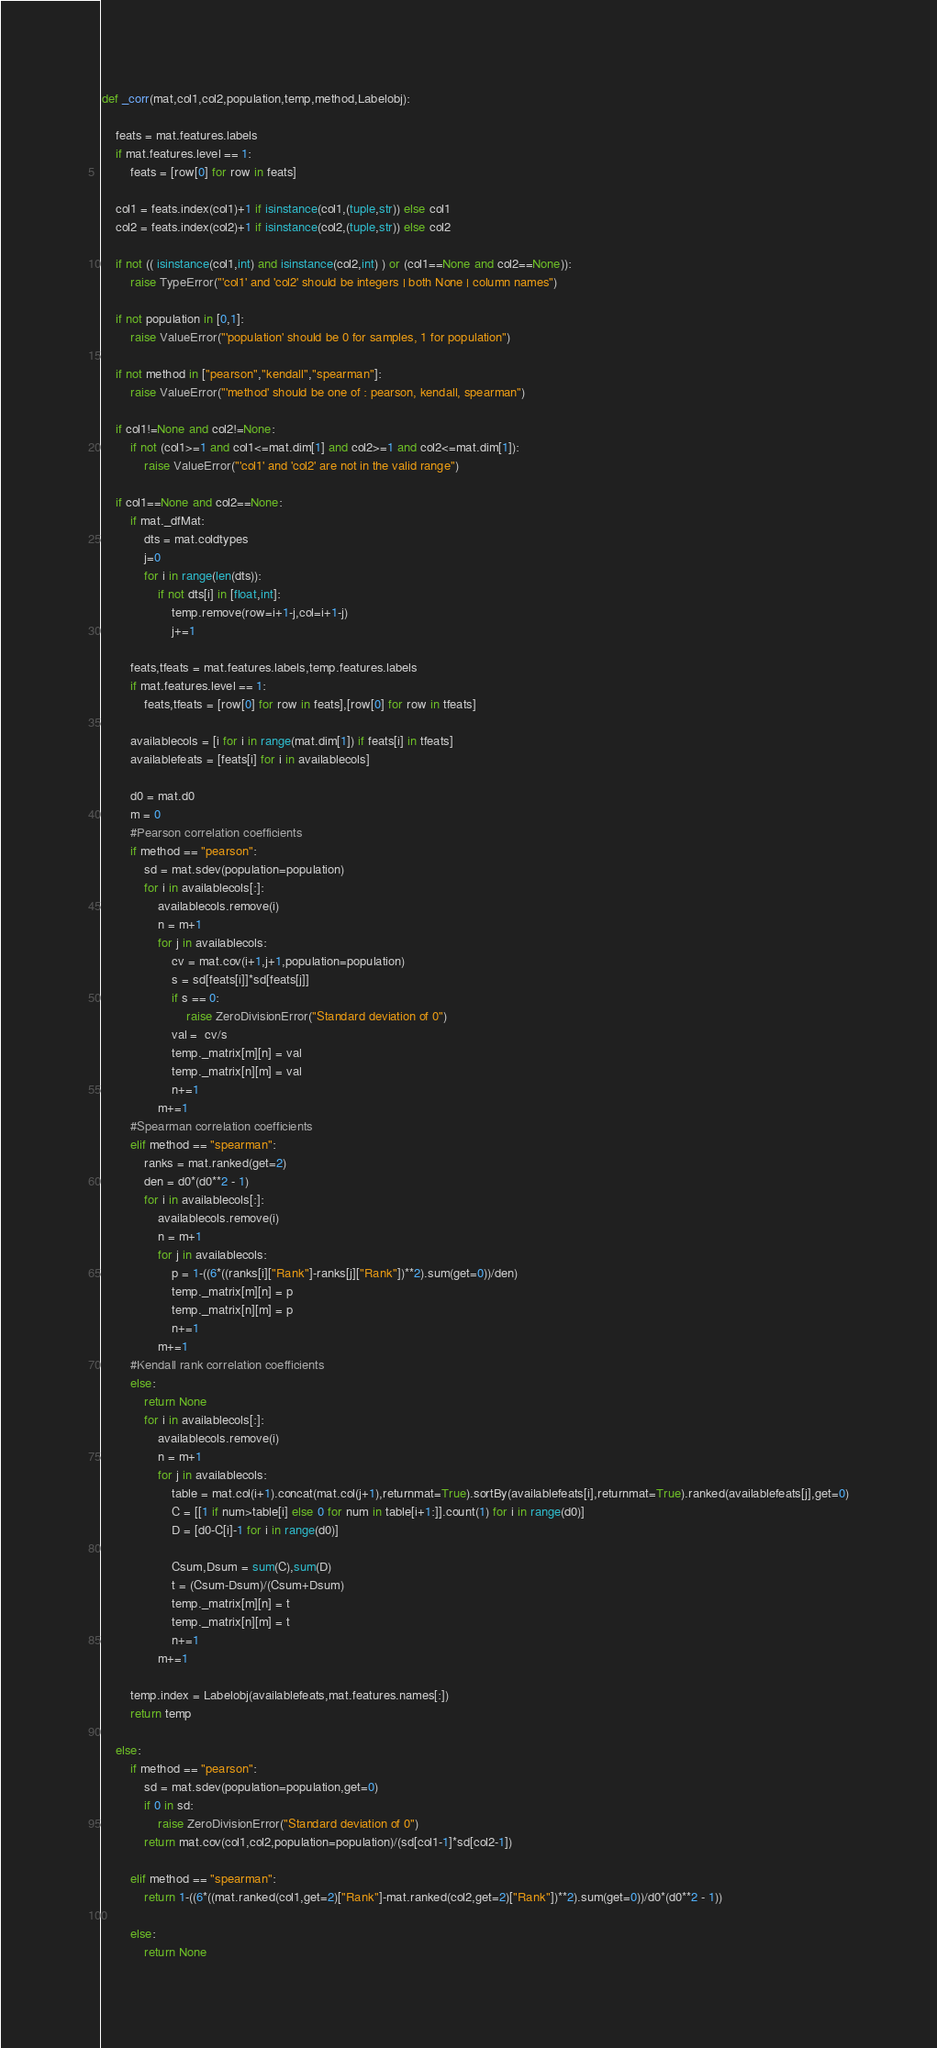Convert code to text. <code><loc_0><loc_0><loc_500><loc_500><_Python_>def _corr(mat,col1,col2,population,temp,method,Labelobj):
    
    feats = mat.features.labels
    if mat.features.level == 1:
        feats = [row[0] for row in feats]

    col1 = feats.index(col1)+1 if isinstance(col1,(tuple,str)) else col1
    col2 = feats.index(col2)+1 if isinstance(col2,(tuple,str)) else col2

    if not (( isinstance(col1,int) and isinstance(col2,int) ) or (col1==None and col2==None)):
        raise TypeError("'col1' and 'col2' should be integers | both None | column names")
        
    if not population in [0,1]:
        raise ValueError("'population' should be 0 for samples, 1 for population")
    
    if not method in ["pearson","kendall","spearman"]:
        raise ValueError("'method' should be one of : pearson, kendall, spearman")

    if col1!=None and col2!=None:
        if not (col1>=1 and col1<=mat.dim[1] and col2>=1 and col2<=mat.dim[1]):
            raise ValueError("'col1' and 'col2' are not in the valid range")
    
    if col1==None and col2==None:
        if mat._dfMat:
            dts = mat.coldtypes
            j=0
            for i in range(len(dts)):
                if not dts[i] in [float,int]:
                    temp.remove(row=i+1-j,col=i+1-j)
                    j+=1

        feats,tfeats = mat.features.labels,temp.features.labels
        if mat.features.level == 1:
            feats,tfeats = [row[0] for row in feats],[row[0] for row in tfeats]

        availablecols = [i for i in range(mat.dim[1]) if feats[i] in tfeats]
        availablefeats = [feats[i] for i in availablecols]
        
        d0 = mat.d0
        m = 0
        #Pearson correlation coefficients
        if method == "pearson":
            sd = mat.sdev(population=population)
            for i in availablecols[:]:
                availablecols.remove(i)
                n = m+1
                for j in availablecols:
                    cv = mat.cov(i+1,j+1,population=population)
                    s = sd[feats[i]]*sd[feats[j]]
                    if s == 0:
                        raise ZeroDivisionError("Standard deviation of 0")
                    val =  cv/s
                    temp._matrix[m][n] = val
                    temp._matrix[n][m] = val
                    n+=1
                m+=1
        #Spearman correlation coefficients
        elif method == "spearman":
            ranks = mat.ranked(get=2)
            den = d0*(d0**2 - 1)
            for i in availablecols[:]:
                availablecols.remove(i)
                n = m+1
                for j in availablecols:
                    p = 1-((6*((ranks[i]["Rank"]-ranks[j]["Rank"])**2).sum(get=0))/den)
                    temp._matrix[m][n] = p
                    temp._matrix[n][m] = p
                    n+=1
                m+=1
        #Kendall rank correlation coefficients
        else:
            return None
            for i in availablecols[:]:
                availablecols.remove(i)
                n = m+1
                for j in availablecols:
                    table = mat.col(i+1).concat(mat.col(j+1),returnmat=True).sortBy(availablefeats[i],returnmat=True).ranked(availablefeats[j],get=0)
                    C = [[1 if num>table[i] else 0 for num in table[i+1:]].count(1) for i in range(d0)]
                    D = [d0-C[i]-1 for i in range(d0)]

                    Csum,Dsum = sum(C),sum(D)
                    t = (Csum-Dsum)/(Csum+Dsum)
                    temp._matrix[m][n] = t
                    temp._matrix[n][m] = t
                    n+=1
                m+=1

        temp.index = Labelobj(availablefeats,mat.features.names[:])
        return temp
    
    else:
        if method == "pearson":
            sd = mat.sdev(population=population,get=0)
            if 0 in sd:
                raise ZeroDivisionError("Standard deviation of 0")
            return mat.cov(col1,col2,population=population)/(sd[col1-1]*sd[col2-1])

        elif method == "spearman":
            return 1-((6*((mat.ranked(col1,get=2)["Rank"]-mat.ranked(col2,get=2)["Rank"])**2).sum(get=0))/d0*(d0**2 - 1))
        
        else:
            return None</code> 